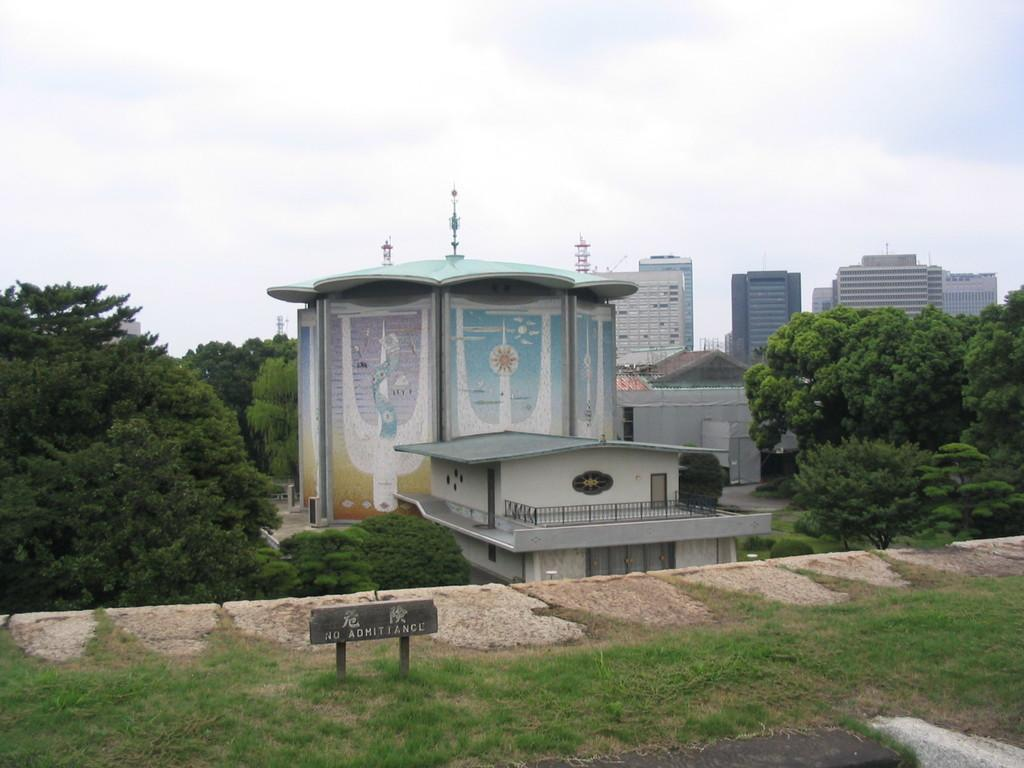What type of surface is at the bottom of the image? There is grass on the ground at the bottom of the image. What object can be seen on the ground in the image? There is a board on the ground. What other objects are on the ground in the image? There are rocks on the ground. What can be seen in the distance in the image? There are buildings visible in the background. What type of vegetation is present in the background of the image? There are trees in the background. What is visible at the top of the image? The sky is visible at the top of the image. How long is the stretch of discussion between the trees in the image? There is no discussion present in the image, as it features a grassy area with a board, rocks, buildings, trees, and the sky. 